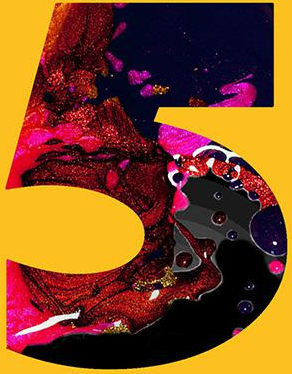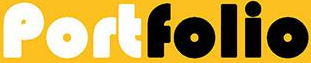What words can you see in these images in sequence, separated by a semicolon? 5; Portfolio 